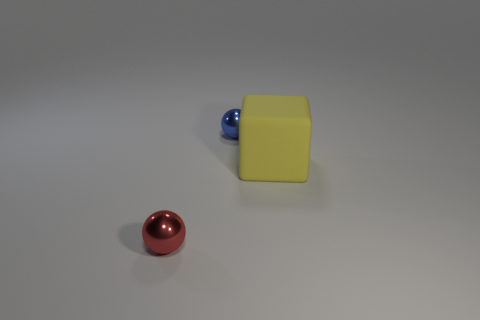There is a small blue thing; is its shape the same as the metallic thing that is in front of the yellow matte thing? Upon closer observation, the small blue object, which appears spherical, shares its spherical shape with the metallic red object positioned in the foreground relative to the larger, yellow matte cube. Both objects are indeed spherical and thus possess the same geometric shape. 